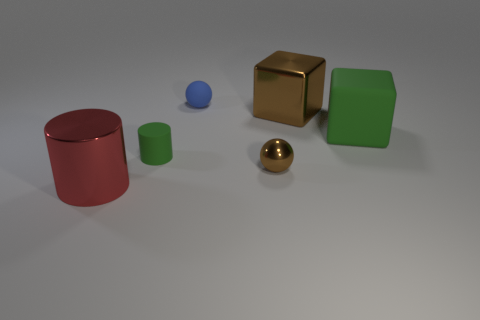Add 4 rubber cubes. How many objects exist? 10 Subtract 1 balls. How many balls are left? 1 Subtract all balls. How many objects are left? 4 Subtract all red balls. How many purple cubes are left? 0 Subtract all gray rubber things. Subtract all brown blocks. How many objects are left? 5 Add 5 tiny brown things. How many tiny brown things are left? 6 Add 6 big brown things. How many big brown things exist? 7 Subtract 0 yellow cubes. How many objects are left? 6 Subtract all brown blocks. Subtract all cyan cylinders. How many blocks are left? 1 